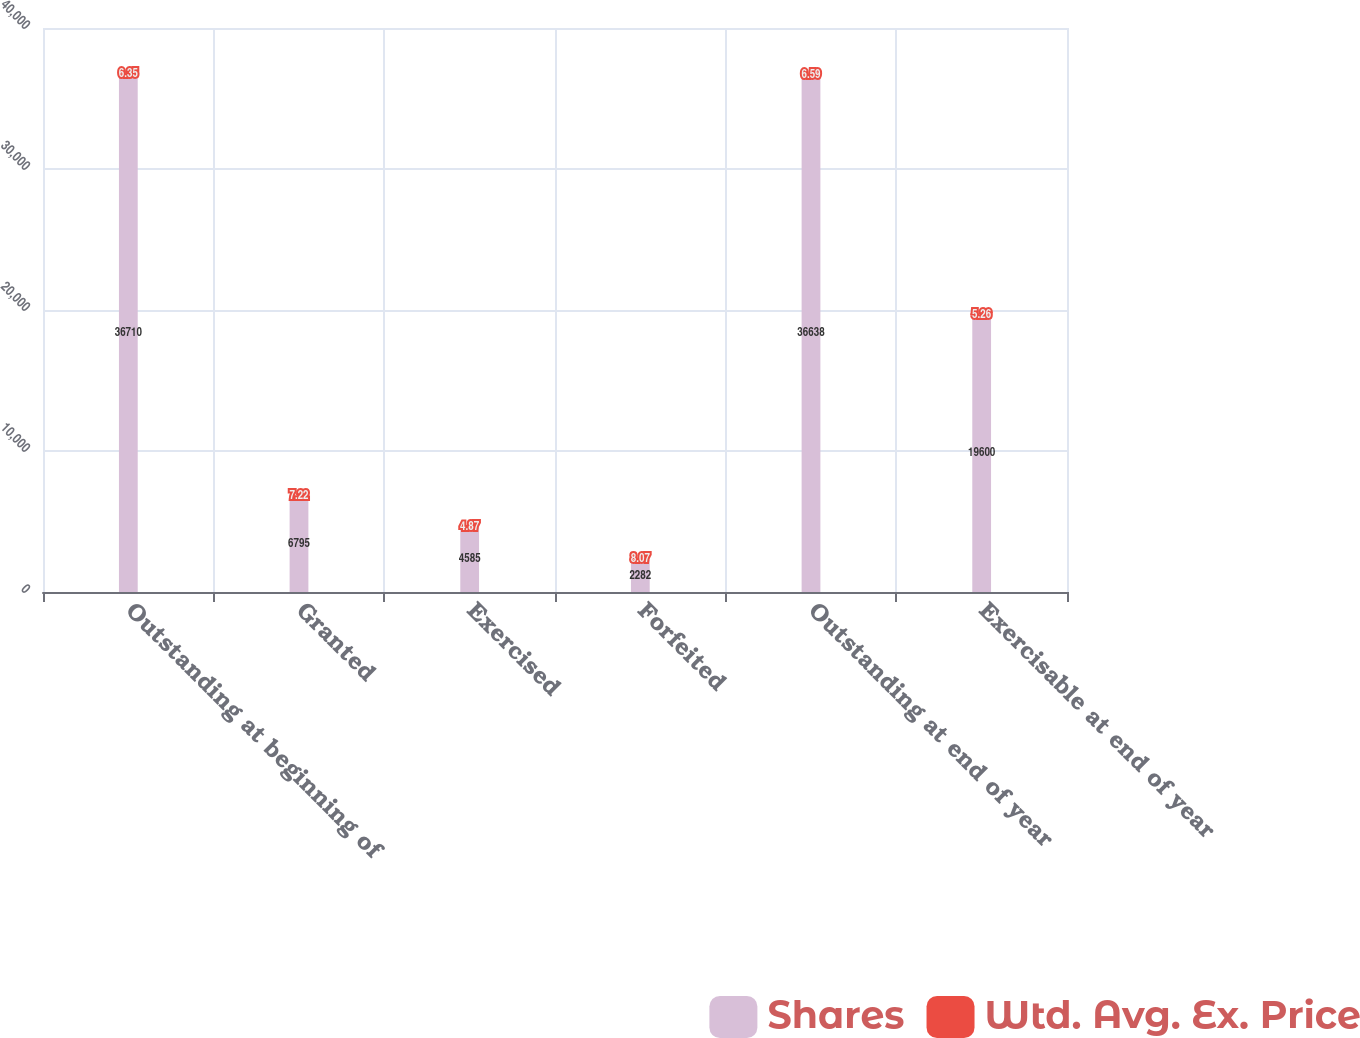Convert chart to OTSL. <chart><loc_0><loc_0><loc_500><loc_500><stacked_bar_chart><ecel><fcel>Outstanding at beginning of<fcel>Granted<fcel>Exercised<fcel>Forfeited<fcel>Outstanding at end of year<fcel>Exercisable at end of year<nl><fcel>Shares<fcel>36710<fcel>6795<fcel>4585<fcel>2282<fcel>36638<fcel>19600<nl><fcel>Wtd. Avg. Ex. Price<fcel>6.35<fcel>7.22<fcel>4.87<fcel>8.07<fcel>6.59<fcel>5.26<nl></chart> 